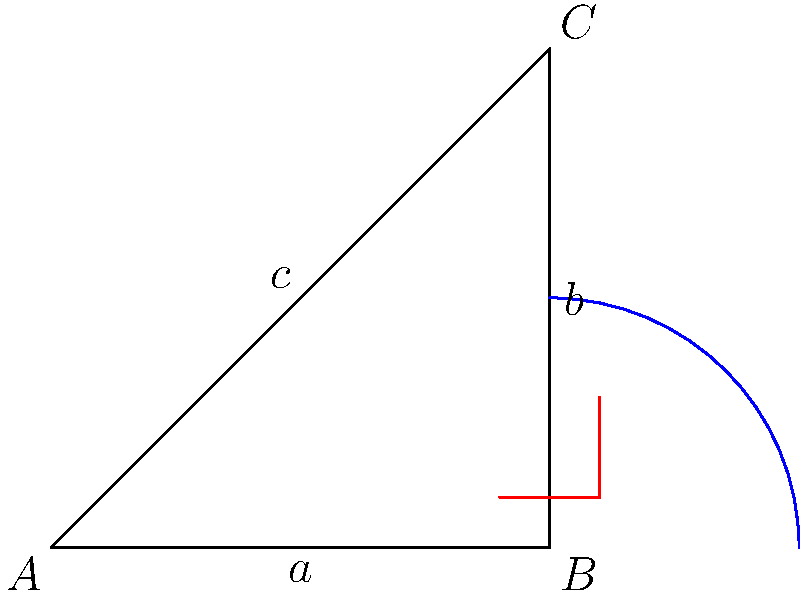In non-Euclidean geometry, the Pythagorean theorem is modified. Consider the image showing a right-angled triangle on a curved surface. How would you express the relationship between the sides $a$, $b$, and $c$ in hyperbolic geometry? To understand how the Pythagorean theorem is modified in non-Euclidean spaces, particularly in hyperbolic geometry, we need to follow these steps:

1. Recall the Euclidean Pythagorean theorem: $a^2 + b^2 = c^2$

2. In hyperbolic geometry, the relationship between the sides of a right-angled triangle is modified due to the curvature of space.

3. The hyperbolic Pythagorean theorem states:

   $\cosh(\frac{c}{R}) = \cosh(\frac{a}{R}) \cosh(\frac{b}{R})$

   Where $R$ is the radius of curvature of the hyperbolic space.

4. This formula uses hyperbolic functions (cosh) instead of simple squares.

5. As the radius of curvature $R$ approaches infinity, the hyperbolic space becomes flatter, and this formula approaches the Euclidean Pythagorean theorem.

6. To see this, we can use the small angle approximation for hyperbolic cosine:

   $\cosh(x) \approx 1 + \frac{x^2}{2}$ for small $x$

7. Substituting this into our hyperbolic Pythagorean theorem:

   $1 + \frac{c^2}{2R^2} \approx (1 + \frac{a^2}{2R^2})(1 + \frac{b^2}{2R^2})$

8. Expanding the right side and neglecting terms of order $\frac{1}{R^4}$:

   $1 + \frac{c^2}{2R^2} \approx 1 + \frac{a^2}{2R^2} + \frac{b^2}{2R^2}$

9. Simplifying:

   $\frac{c^2}{2R^2} \approx \frac{a^2}{2R^2} + \frac{b^2}{2R^2}$

10. Multiplying both sides by $2R^2$:

    $c^2 \approx a^2 + b^2$

This demonstrates how the hyperbolic Pythagorean theorem approaches the Euclidean version as $R$ becomes very large.
Answer: $\cosh(\frac{c}{R}) = \cosh(\frac{a}{R}) \cosh(\frac{b}{R})$ 